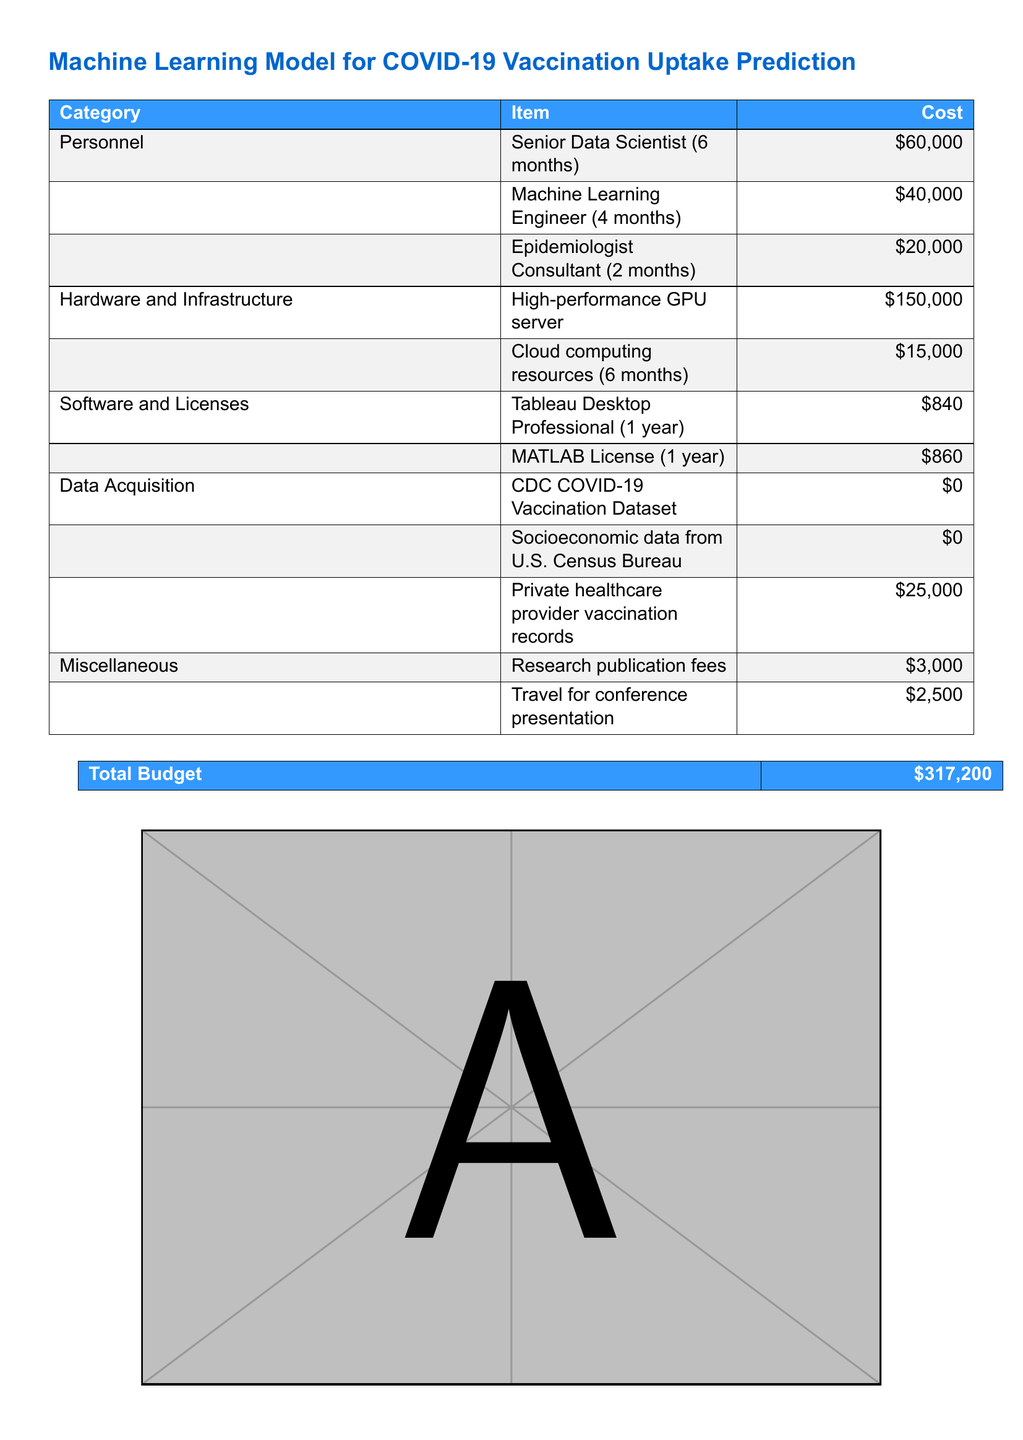What is the total budget? The total budget is the final line in the document summarizing all costs, which is $317,200.
Answer: $317,200 How much is allocated for the Senior Data Scientist? The allocation for the Senior Data Scientist is explicitly stated in the budget table as $60,000.
Answer: $60,000 What is the cost of the high-performance GPU server? The cost of the high-performance GPU server is detailed in the budget table as $150,000.
Answer: $150,000 How many months is the Machine Learning Engineer's position funded for? The duration for which the Machine Learning Engineer position is funded is provided in the budget table as 4 months.
Answer: 4 months What is the cost of data acquisition from private healthcare provider vaccination records? The cost for acquiring private healthcare provider vaccination records is listed as $25,000 in the budget.
Answer: $25,000 What role has the shortest duration in terms of funding? The role with the shortest funding duration is the Epidemiologist Consultant for 2 months.
Answer: Epidemiologist Consultant What is the total cost of software and licenses? The total cost of software and licenses can be calculated by adding $840 for Tableau and $860 for MATLAB, totaling $1,700.
Answer: $1,700 What miscellaneous expense is the highest? The highest miscellaneous expense is the research publication fees at $3,000.
Answer: $3,000 What is the main purpose of this document? The main purpose of this document is to propose funds for developing a machine learning model to predict COVID-19 vaccination uptake.
Answer: Predict vaccination uptake 